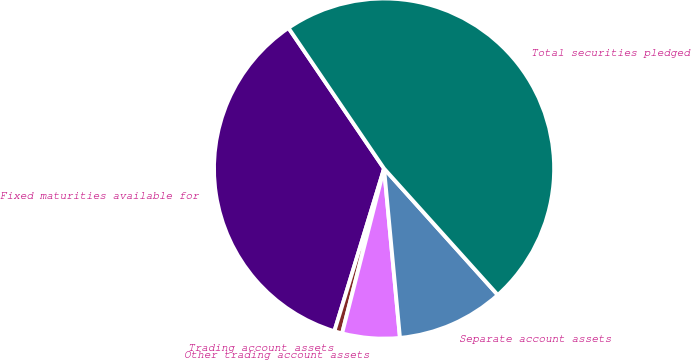<chart> <loc_0><loc_0><loc_500><loc_500><pie_chart><fcel>Fixed maturities available for<fcel>Trading account assets<fcel>Other trading account assets<fcel>Separate account assets<fcel>Total securities pledged<nl><fcel>35.78%<fcel>0.75%<fcel>5.46%<fcel>10.17%<fcel>47.84%<nl></chart> 